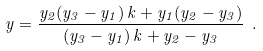<formula> <loc_0><loc_0><loc_500><loc_500>y = \frac { y _ { 2 } ( y _ { 3 } - y _ { 1 } ) \, k + y _ { 1 } ( y _ { 2 } - y _ { 3 } ) } { ( y _ { 3 } - y _ { 1 } ) \, k + y _ { 2 } - y _ { 3 } } \ .</formula> 